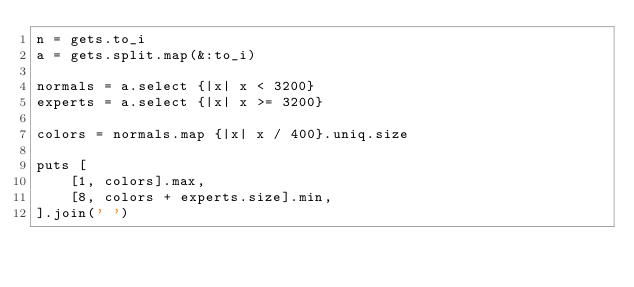<code> <loc_0><loc_0><loc_500><loc_500><_Ruby_>n = gets.to_i
a = gets.split.map(&:to_i)

normals = a.select {|x| x < 3200}
experts = a.select {|x| x >= 3200}

colors = normals.map {|x| x / 400}.uniq.size

puts [
    [1, colors].max,
    [8, colors + experts.size].min,
].join(' ')</code> 